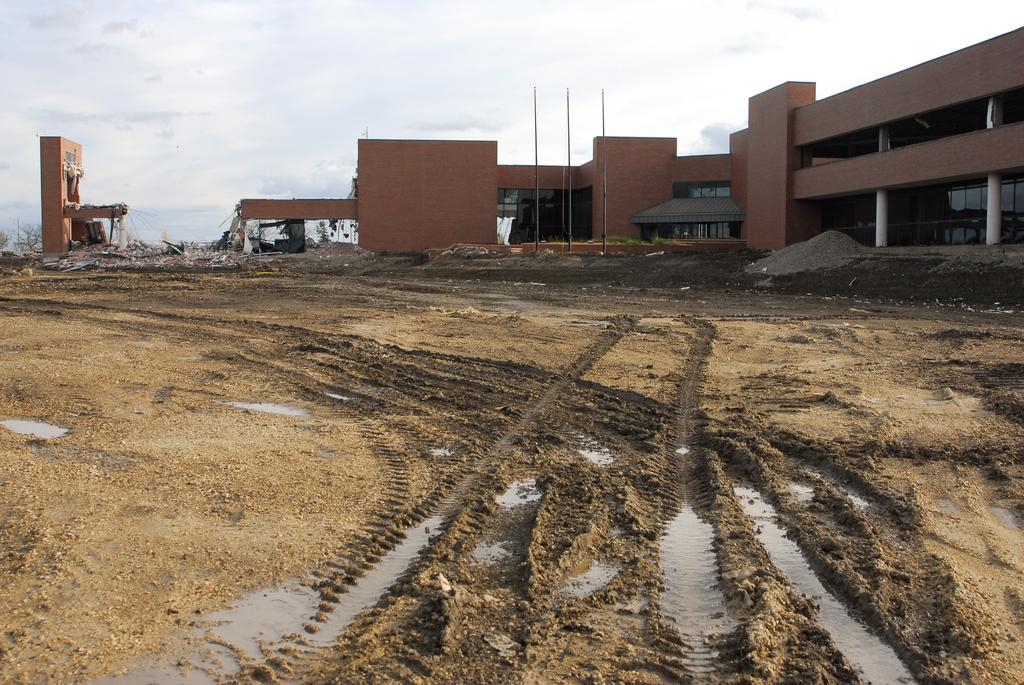What type of structures are present in the image? There are buildings in the image. What features can be observed on the buildings? The buildings have windows and pillars. What is visible on the ground in the image? There is water visible on the ground in the image. What else can be seen in the image besides the buildings and water? There are objects and poles in the image. What part of the natural environment is visible in the image? The sky is visible in the image. Where is the faucet located in the image? There is no faucet present in the image. What type of request is being made in the image? There is no request being made in the image. 